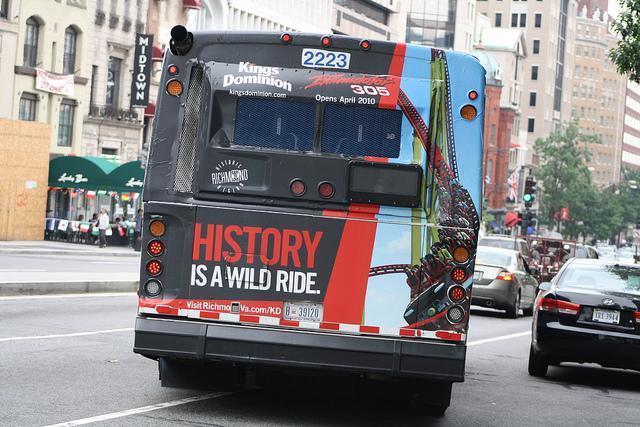How many cars are there?
Give a very brief answer. 2. How many drinks cups have straw?
Give a very brief answer. 0. 